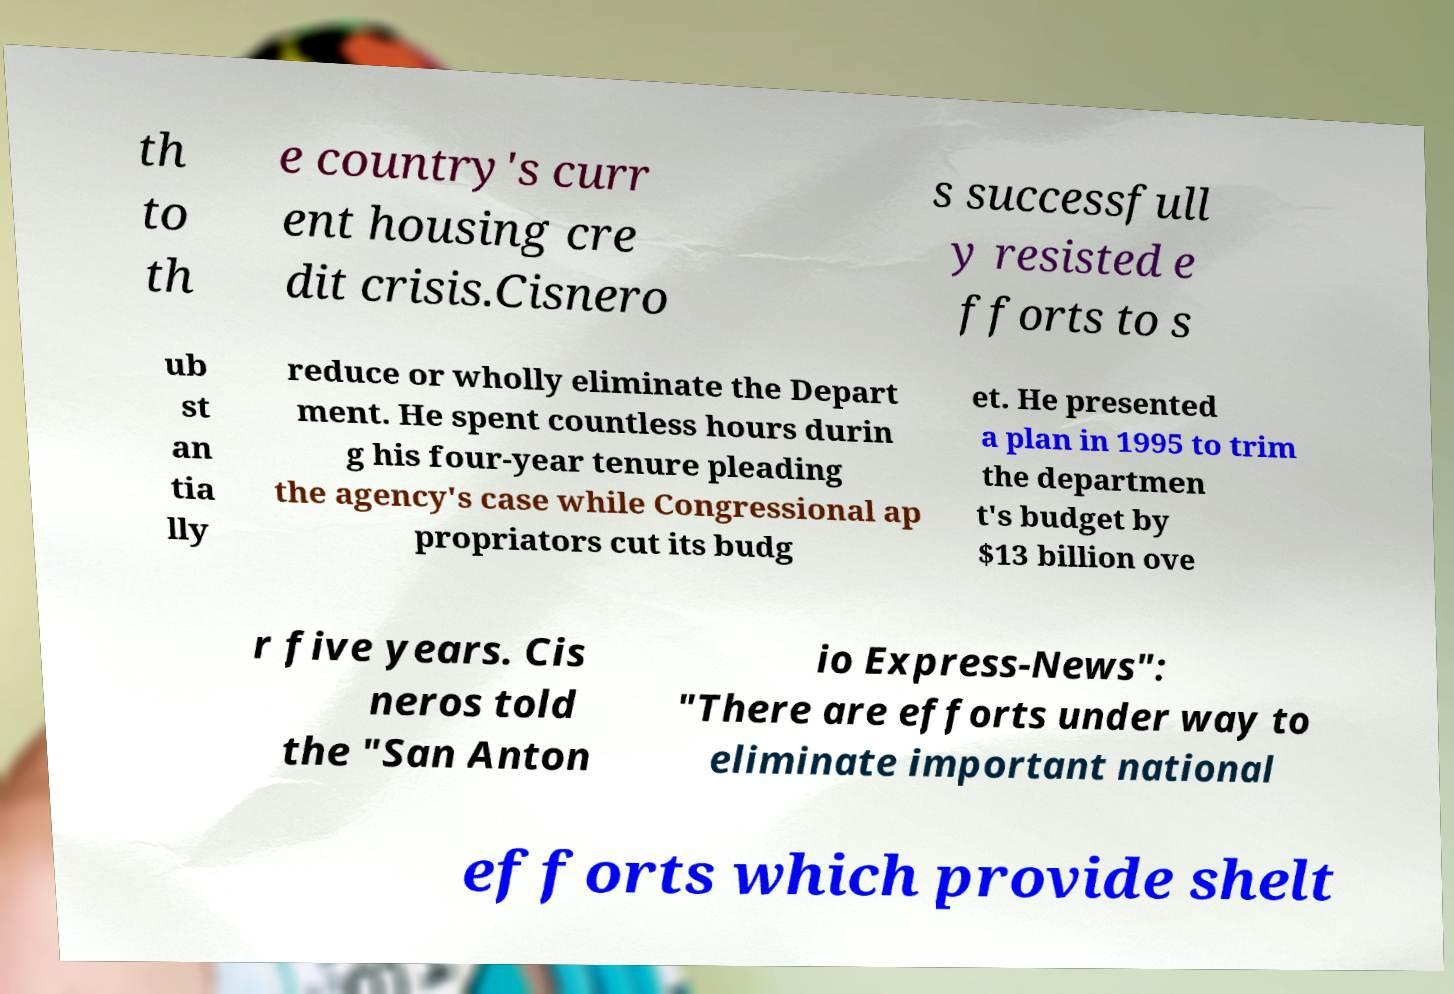For documentation purposes, I need the text within this image transcribed. Could you provide that? th to th e country's curr ent housing cre dit crisis.Cisnero s successfull y resisted e fforts to s ub st an tia lly reduce or wholly eliminate the Depart ment. He spent countless hours durin g his four-year tenure pleading the agency's case while Congressional ap propriators cut its budg et. He presented a plan in 1995 to trim the departmen t's budget by $13 billion ove r five years. Cis neros told the "San Anton io Express-News": "There are efforts under way to eliminate important national efforts which provide shelt 